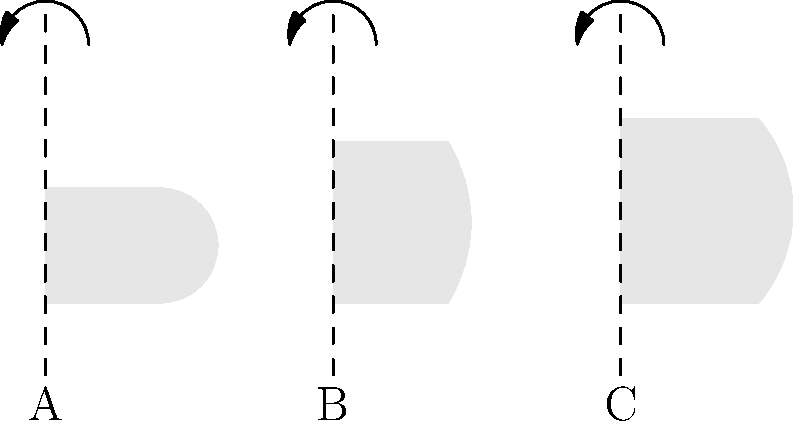As a veterinarian studying animal skull morphology, you're analyzing the symmetry of different skull shapes after rotation. The image shows three animal skull outlines (A, B, and C) with vertical axes of rotation. If each skull is rotated 180° around its respective axis, which skull(s) will demonstrate rotational symmetry, appearing identical to its original position? To determine which skull(s) demonstrate rotational symmetry after a 180° rotation, we need to analyze each skull shape:

1. Skull A:
   - It has a rounded top and a flat bottom.
   - After a 180° rotation, the flat bottom would be at the top, and the rounded part at the bottom.
   - This would not match the original position, so Skull A does not have rotational symmetry.

2. Skull B:
   - It has a symmetrical shape with a pointed top and a flat bottom.
   - After a 180° rotation, the shape would remain the same.
   - The pointed top would become the bottom, and the flat bottom would become the top, matching the original shape.
   - Skull B demonstrates rotational symmetry.

3. Skull C:
   - It has an asymmetrical shape with a longer, more pointed top compared to the bottom.
   - After a 180° rotation, the longer, pointed part would be at the bottom, which doesn't match the original position.
   - Skull C does not have rotational symmetry.

In conclusion, only Skull B demonstrates rotational symmetry when rotated 180° around its vertical axis.
Answer: Skull B 